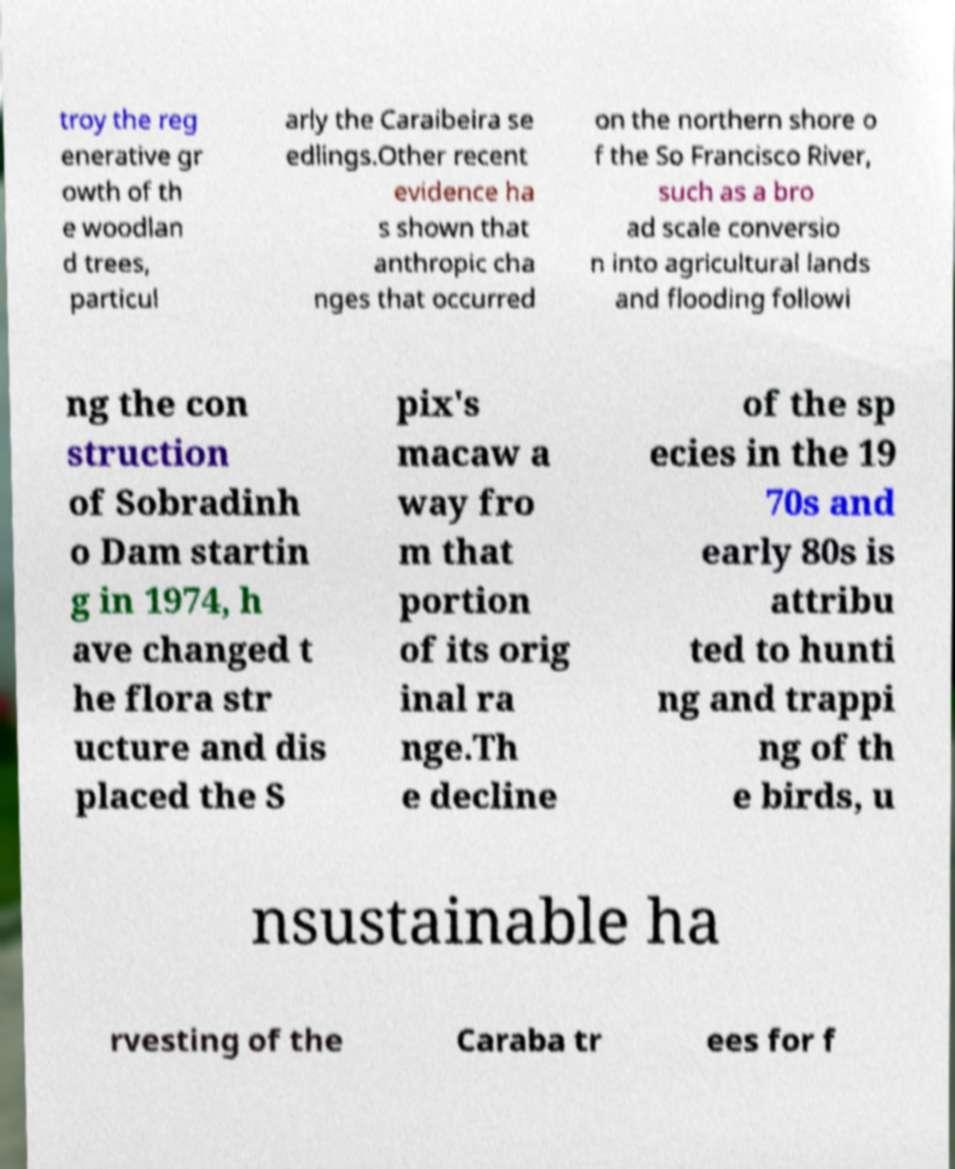For documentation purposes, I need the text within this image transcribed. Could you provide that? troy the reg enerative gr owth of th e woodlan d trees, particul arly the Caraibeira se edlings.Other recent evidence ha s shown that anthropic cha nges that occurred on the northern shore o f the So Francisco River, such as a bro ad scale conversio n into agricultural lands and flooding followi ng the con struction of Sobradinh o Dam startin g in 1974, h ave changed t he flora str ucture and dis placed the S pix's macaw a way fro m that portion of its orig inal ra nge.Th e decline of the sp ecies in the 19 70s and early 80s is attribu ted to hunti ng and trappi ng of th e birds, u nsustainable ha rvesting of the Caraba tr ees for f 